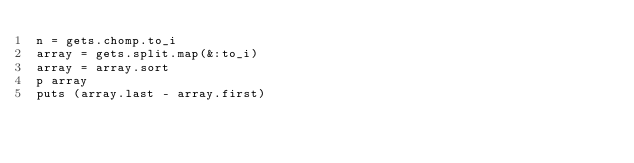Convert code to text. <code><loc_0><loc_0><loc_500><loc_500><_Ruby_>n = gets.chomp.to_i
array = gets.split.map(&:to_i)
array = array.sort
p array
puts (array.last - array.first)
</code> 